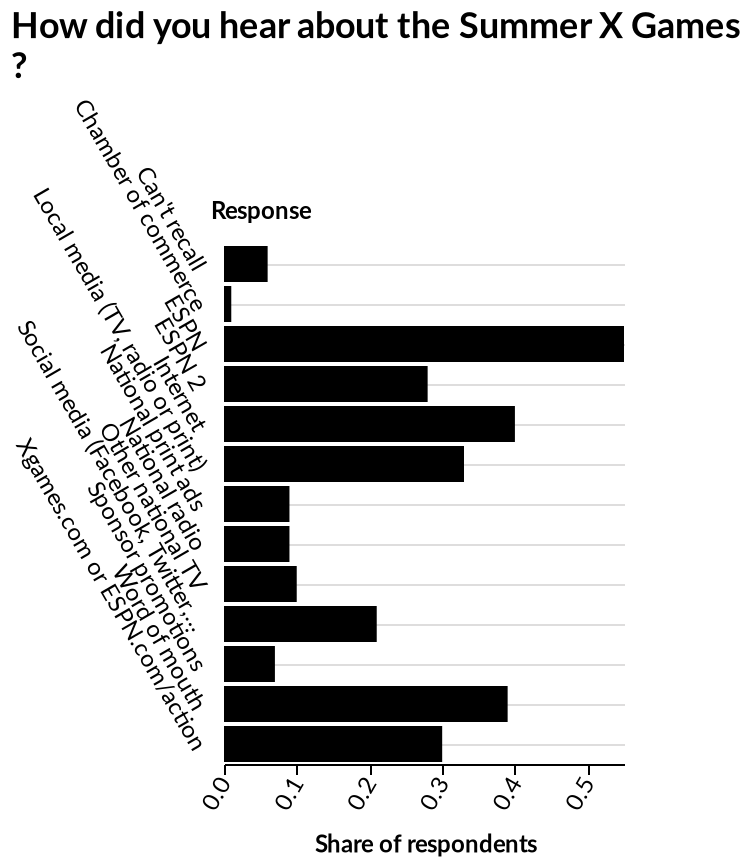<image>
What was the highest proportion of respondents who heard about the summer X games through ESPN?  The highest proportion of respondents who heard about the summer X games through ESPN was not specified in the description. please enumerates aspects of the construction of the chart Here a is a bar diagram labeled How did you hear about the Summer X Games ?. The y-axis shows Response. On the x-axis, Share of respondents is drawn on a linear scale of range 0.0 to 0.5. 